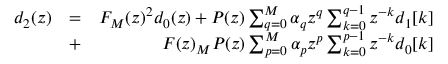Convert formula to latex. <formula><loc_0><loc_0><loc_500><loc_500>\begin{array} { r l r } { d _ { 2 } ( z ) } & { = } & { F _ { M } ( z ) ^ { 2 } d _ { 0 } ( z ) + P ( z ) \sum _ { q = 0 } ^ { M } \alpha _ { q } z ^ { q } \sum _ { k = 0 } ^ { q - 1 } z ^ { - k } { d _ { 1 } [ k ] } } \\ & { + } & { F ( z ) _ { M } P ( z ) \sum _ { p = 0 } ^ { M } \alpha _ { p } z ^ { p } \sum _ { k = 0 } ^ { p - 1 } z ^ { - k } d _ { 0 } [ k ] } \end{array}</formula> 